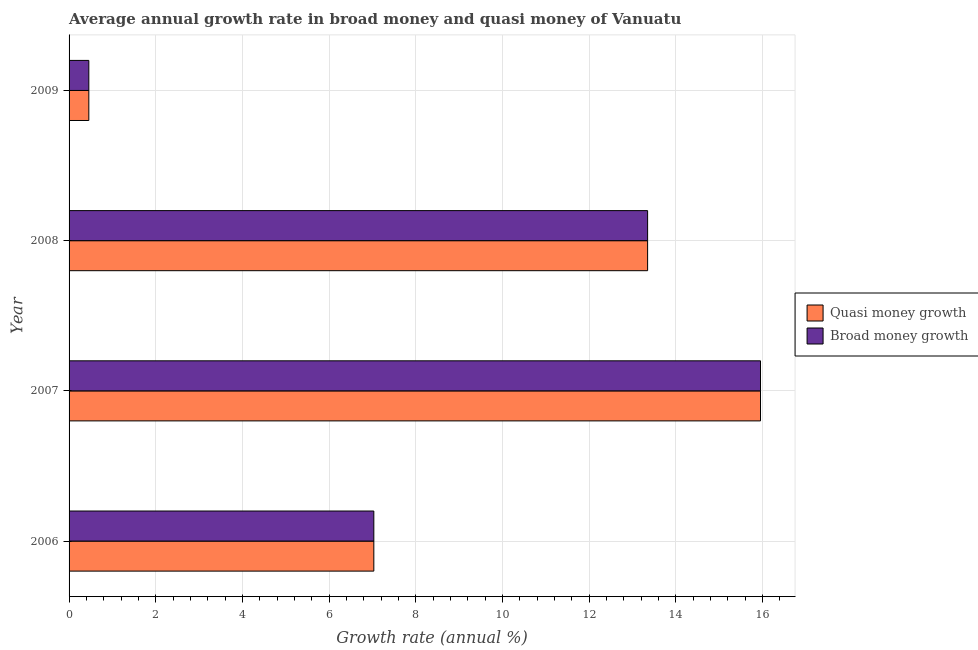How many different coloured bars are there?
Your answer should be compact. 2. How many groups of bars are there?
Offer a very short reply. 4. Are the number of bars per tick equal to the number of legend labels?
Provide a succinct answer. Yes. Are the number of bars on each tick of the Y-axis equal?
Your response must be concise. Yes. In how many cases, is the number of bars for a given year not equal to the number of legend labels?
Your answer should be compact. 0. What is the annual growth rate in quasi money in 2008?
Provide a succinct answer. 13.35. Across all years, what is the maximum annual growth rate in quasi money?
Keep it short and to the point. 15.96. Across all years, what is the minimum annual growth rate in broad money?
Offer a terse response. 0.46. What is the total annual growth rate in broad money in the graph?
Offer a very short reply. 36.8. What is the difference between the annual growth rate in quasi money in 2007 and that in 2009?
Ensure brevity in your answer.  15.5. What is the difference between the annual growth rate in broad money in 2008 and the annual growth rate in quasi money in 2006?
Keep it short and to the point. 6.32. What is the average annual growth rate in quasi money per year?
Your answer should be compact. 9.2. In the year 2009, what is the difference between the annual growth rate in broad money and annual growth rate in quasi money?
Provide a short and direct response. 0. In how many years, is the annual growth rate in quasi money greater than 12.4 %?
Offer a very short reply. 2. What is the ratio of the annual growth rate in broad money in 2006 to that in 2009?
Provide a short and direct response. 15.42. Is the annual growth rate in broad money in 2008 less than that in 2009?
Keep it short and to the point. No. Is the difference between the annual growth rate in broad money in 2006 and 2009 greater than the difference between the annual growth rate in quasi money in 2006 and 2009?
Your answer should be compact. No. What is the difference between the highest and the second highest annual growth rate in broad money?
Your response must be concise. 2.6. Is the sum of the annual growth rate in quasi money in 2007 and 2008 greater than the maximum annual growth rate in broad money across all years?
Your answer should be very brief. Yes. What does the 1st bar from the top in 2009 represents?
Your answer should be compact. Broad money growth. What does the 2nd bar from the bottom in 2009 represents?
Provide a succinct answer. Broad money growth. How many bars are there?
Ensure brevity in your answer.  8. Are all the bars in the graph horizontal?
Offer a terse response. Yes. How many years are there in the graph?
Offer a very short reply. 4. What is the difference between two consecutive major ticks on the X-axis?
Offer a very short reply. 2. Does the graph contain any zero values?
Provide a short and direct response. No. Where does the legend appear in the graph?
Offer a very short reply. Center right. How many legend labels are there?
Make the answer very short. 2. What is the title of the graph?
Give a very brief answer. Average annual growth rate in broad money and quasi money of Vanuatu. Does "National Tourists" appear as one of the legend labels in the graph?
Your answer should be compact. No. What is the label or title of the X-axis?
Your answer should be compact. Growth rate (annual %). What is the label or title of the Y-axis?
Make the answer very short. Year. What is the Growth rate (annual %) of Quasi money growth in 2006?
Keep it short and to the point. 7.03. What is the Growth rate (annual %) of Broad money growth in 2006?
Provide a succinct answer. 7.03. What is the Growth rate (annual %) of Quasi money growth in 2007?
Provide a short and direct response. 15.96. What is the Growth rate (annual %) of Broad money growth in 2007?
Your answer should be very brief. 15.96. What is the Growth rate (annual %) in Quasi money growth in 2008?
Provide a short and direct response. 13.35. What is the Growth rate (annual %) of Broad money growth in 2008?
Ensure brevity in your answer.  13.35. What is the Growth rate (annual %) in Quasi money growth in 2009?
Provide a succinct answer. 0.46. What is the Growth rate (annual %) in Broad money growth in 2009?
Keep it short and to the point. 0.46. Across all years, what is the maximum Growth rate (annual %) in Quasi money growth?
Your answer should be compact. 15.96. Across all years, what is the maximum Growth rate (annual %) of Broad money growth?
Provide a succinct answer. 15.96. Across all years, what is the minimum Growth rate (annual %) of Quasi money growth?
Provide a succinct answer. 0.46. Across all years, what is the minimum Growth rate (annual %) in Broad money growth?
Your response must be concise. 0.46. What is the total Growth rate (annual %) in Quasi money growth in the graph?
Ensure brevity in your answer.  36.8. What is the total Growth rate (annual %) of Broad money growth in the graph?
Your answer should be very brief. 36.8. What is the difference between the Growth rate (annual %) in Quasi money growth in 2006 and that in 2007?
Offer a very short reply. -8.92. What is the difference between the Growth rate (annual %) in Broad money growth in 2006 and that in 2007?
Make the answer very short. -8.92. What is the difference between the Growth rate (annual %) of Quasi money growth in 2006 and that in 2008?
Offer a very short reply. -6.32. What is the difference between the Growth rate (annual %) of Broad money growth in 2006 and that in 2008?
Your response must be concise. -6.32. What is the difference between the Growth rate (annual %) of Quasi money growth in 2006 and that in 2009?
Keep it short and to the point. 6.58. What is the difference between the Growth rate (annual %) of Broad money growth in 2006 and that in 2009?
Provide a succinct answer. 6.58. What is the difference between the Growth rate (annual %) of Quasi money growth in 2007 and that in 2008?
Provide a short and direct response. 2.61. What is the difference between the Growth rate (annual %) of Broad money growth in 2007 and that in 2008?
Provide a succinct answer. 2.61. What is the difference between the Growth rate (annual %) of Quasi money growth in 2007 and that in 2009?
Offer a very short reply. 15.5. What is the difference between the Growth rate (annual %) in Broad money growth in 2007 and that in 2009?
Your answer should be very brief. 15.5. What is the difference between the Growth rate (annual %) of Quasi money growth in 2008 and that in 2009?
Offer a terse response. 12.9. What is the difference between the Growth rate (annual %) in Broad money growth in 2008 and that in 2009?
Provide a short and direct response. 12.9. What is the difference between the Growth rate (annual %) in Quasi money growth in 2006 and the Growth rate (annual %) in Broad money growth in 2007?
Keep it short and to the point. -8.92. What is the difference between the Growth rate (annual %) in Quasi money growth in 2006 and the Growth rate (annual %) in Broad money growth in 2008?
Offer a very short reply. -6.32. What is the difference between the Growth rate (annual %) in Quasi money growth in 2006 and the Growth rate (annual %) in Broad money growth in 2009?
Ensure brevity in your answer.  6.58. What is the difference between the Growth rate (annual %) of Quasi money growth in 2007 and the Growth rate (annual %) of Broad money growth in 2008?
Your response must be concise. 2.61. What is the difference between the Growth rate (annual %) of Quasi money growth in 2007 and the Growth rate (annual %) of Broad money growth in 2009?
Provide a short and direct response. 15.5. What is the difference between the Growth rate (annual %) of Quasi money growth in 2008 and the Growth rate (annual %) of Broad money growth in 2009?
Offer a very short reply. 12.9. What is the average Growth rate (annual %) of Quasi money growth per year?
Your answer should be very brief. 9.2. What is the average Growth rate (annual %) of Broad money growth per year?
Provide a succinct answer. 9.2. In the year 2007, what is the difference between the Growth rate (annual %) in Quasi money growth and Growth rate (annual %) in Broad money growth?
Provide a short and direct response. 0. What is the ratio of the Growth rate (annual %) in Quasi money growth in 2006 to that in 2007?
Ensure brevity in your answer.  0.44. What is the ratio of the Growth rate (annual %) of Broad money growth in 2006 to that in 2007?
Your response must be concise. 0.44. What is the ratio of the Growth rate (annual %) of Quasi money growth in 2006 to that in 2008?
Provide a succinct answer. 0.53. What is the ratio of the Growth rate (annual %) in Broad money growth in 2006 to that in 2008?
Your answer should be very brief. 0.53. What is the ratio of the Growth rate (annual %) of Quasi money growth in 2006 to that in 2009?
Keep it short and to the point. 15.42. What is the ratio of the Growth rate (annual %) of Broad money growth in 2006 to that in 2009?
Your response must be concise. 15.42. What is the ratio of the Growth rate (annual %) of Quasi money growth in 2007 to that in 2008?
Your answer should be compact. 1.2. What is the ratio of the Growth rate (annual %) of Broad money growth in 2007 to that in 2008?
Keep it short and to the point. 1.2. What is the ratio of the Growth rate (annual %) of Quasi money growth in 2007 to that in 2009?
Make the answer very short. 34.99. What is the ratio of the Growth rate (annual %) in Broad money growth in 2007 to that in 2009?
Make the answer very short. 34.99. What is the ratio of the Growth rate (annual %) of Quasi money growth in 2008 to that in 2009?
Your answer should be very brief. 29.27. What is the ratio of the Growth rate (annual %) of Broad money growth in 2008 to that in 2009?
Your answer should be very brief. 29.27. What is the difference between the highest and the second highest Growth rate (annual %) in Quasi money growth?
Your answer should be very brief. 2.61. What is the difference between the highest and the second highest Growth rate (annual %) of Broad money growth?
Your answer should be very brief. 2.61. What is the difference between the highest and the lowest Growth rate (annual %) in Quasi money growth?
Ensure brevity in your answer.  15.5. What is the difference between the highest and the lowest Growth rate (annual %) of Broad money growth?
Offer a terse response. 15.5. 